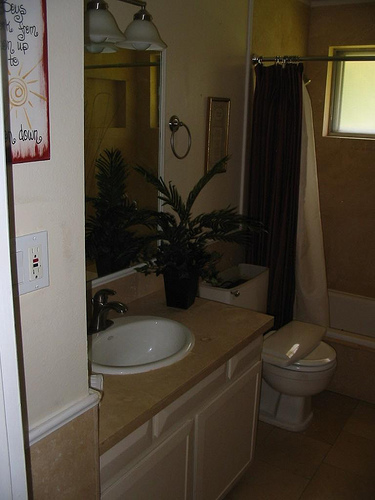Read and extract the text from this image. EUS up 